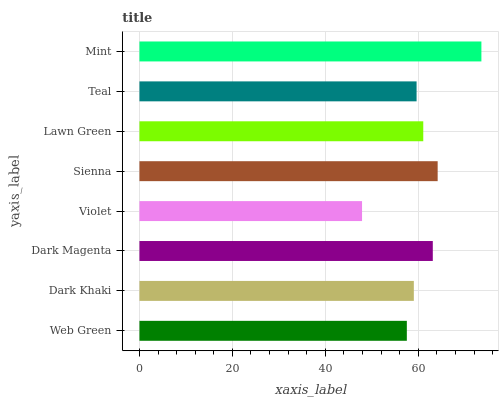Is Violet the minimum?
Answer yes or no. Yes. Is Mint the maximum?
Answer yes or no. Yes. Is Dark Khaki the minimum?
Answer yes or no. No. Is Dark Khaki the maximum?
Answer yes or no. No. Is Dark Khaki greater than Web Green?
Answer yes or no. Yes. Is Web Green less than Dark Khaki?
Answer yes or no. Yes. Is Web Green greater than Dark Khaki?
Answer yes or no. No. Is Dark Khaki less than Web Green?
Answer yes or no. No. Is Lawn Green the high median?
Answer yes or no. Yes. Is Teal the low median?
Answer yes or no. Yes. Is Violet the high median?
Answer yes or no. No. Is Violet the low median?
Answer yes or no. No. 